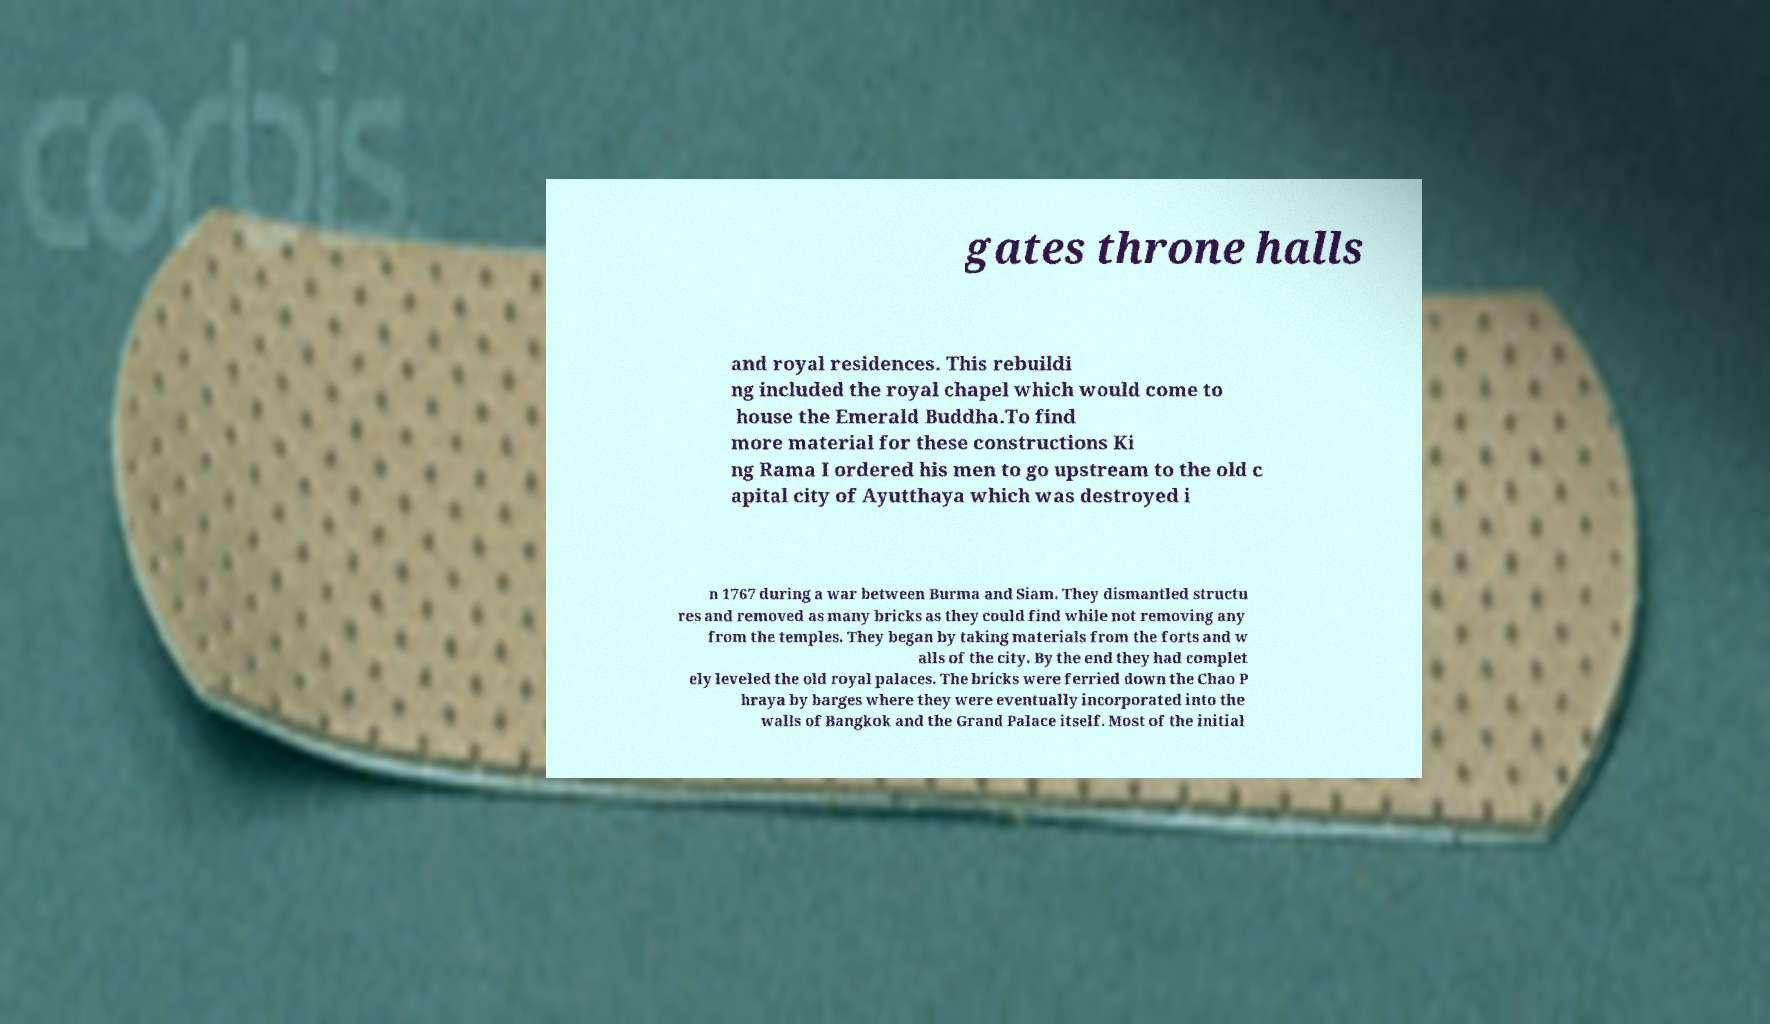I need the written content from this picture converted into text. Can you do that? gates throne halls and royal residences. This rebuildi ng included the royal chapel which would come to house the Emerald Buddha.To find more material for these constructions Ki ng Rama I ordered his men to go upstream to the old c apital city of Ayutthaya which was destroyed i n 1767 during a war between Burma and Siam. They dismantled structu res and removed as many bricks as they could find while not removing any from the temples. They began by taking materials from the forts and w alls of the city. By the end they had complet ely leveled the old royal palaces. The bricks were ferried down the Chao P hraya by barges where they were eventually incorporated into the walls of Bangkok and the Grand Palace itself. Most of the initial 